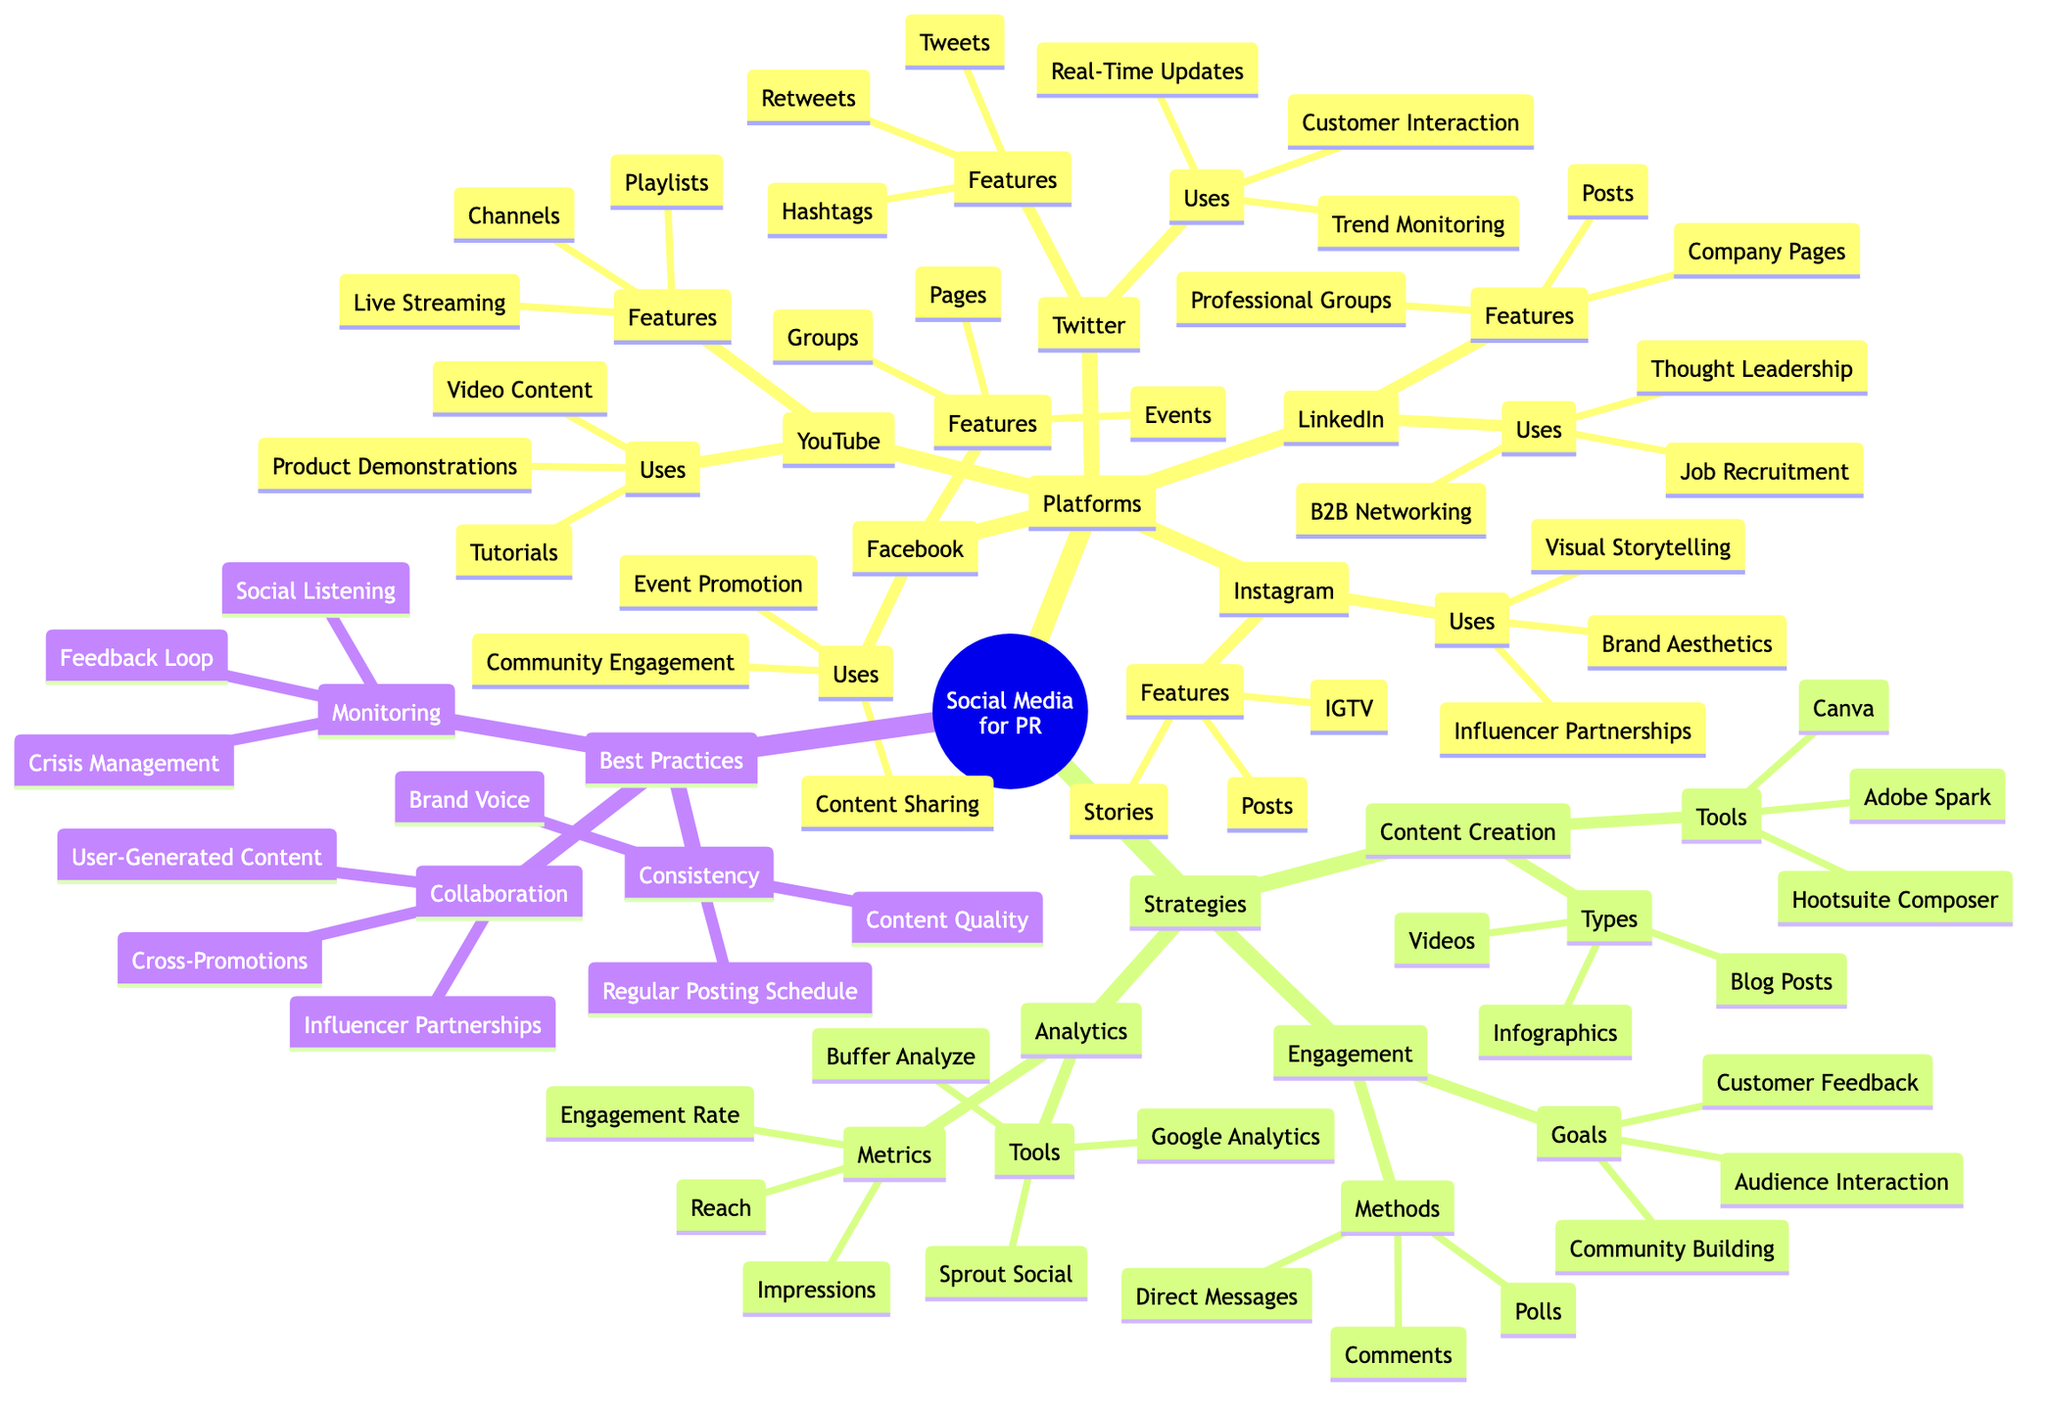What are the features of Twitter? The diagram lists the features under the Twitter node. The features include Tweets, Retweets, and Hashtags.
Answer: Tweets, Retweets, Hashtags How many platforms are listed in the diagram? The platform section contains five individual nodes: Facebook, Twitter, LinkedIn, Instagram, and YouTube. Thus, by counting these nodes, we conclude that there are five platforms.
Answer: 5 What is the main use of Instagram according to the diagram? The Uses section under Instagram indicates three main uses: Visual Storytelling, Brand Aesthetics, and Influencer Partnerships. The primary or first use is typically highlighted, which is Visual Storytelling.
Answer: Visual Storytelling What types of metrics are used in the Analytics strategy? The Analytics node lists three specific metrics: Engagement Rate, Reach, and Impressions. Therefore, these metrics are understood to be the focus of this strategy.
Answer: Engagement Rate, Reach, Impressions What is the goal of audience interaction under Engagement? The Goals listed under Engagement include Customer Feedback, Audience Interaction, and Community Building. The goal that specifically addresses interaction is Audience Interaction.
Answer: Audience Interaction What tools are suggested for content creation? The diagram lists the tools under the Content Creation strategy, which includes Canva, Adobe Spark, and Hootsuite Composer. Therefore, these are the tools recommended for content creation.
Answer: Canva, Adobe Spark, Hootsuite Composer What is a key aspect of the Best Practices section? The Best Practices section contains three key aspects: Consistency, Monitoring, and Collaboration. Each aspect emphasizes good PR practices. The essence here is that these elements together contribute to effective public relations efforts.
Answer: Consistency, Monitoring, Collaboration How many key strategies are identified for Social Media Platforms in PR? The diagram defines three strategies: Content Creation, Analytics, and Engagement. Counting these provides the number of strategies identified for public relations.
Answer: 3 